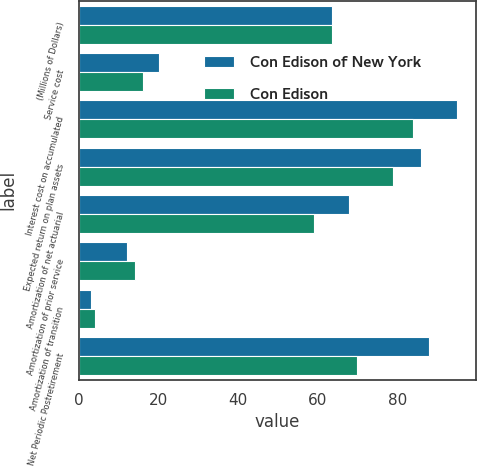<chart> <loc_0><loc_0><loc_500><loc_500><stacked_bar_chart><ecel><fcel>(Millions of Dollars)<fcel>Service cost<fcel>Interest cost on accumulated<fcel>Expected return on plan assets<fcel>Amortization of net actuarial<fcel>Amortization of prior service<fcel>Amortization of transition<fcel>Net Periodic Postretirement<nl><fcel>Con Edison of New York<fcel>63.5<fcel>20<fcel>95<fcel>86<fcel>68<fcel>12<fcel>3<fcel>88<nl><fcel>Con Edison<fcel>63.5<fcel>16<fcel>84<fcel>79<fcel>59<fcel>14<fcel>4<fcel>70<nl></chart> 